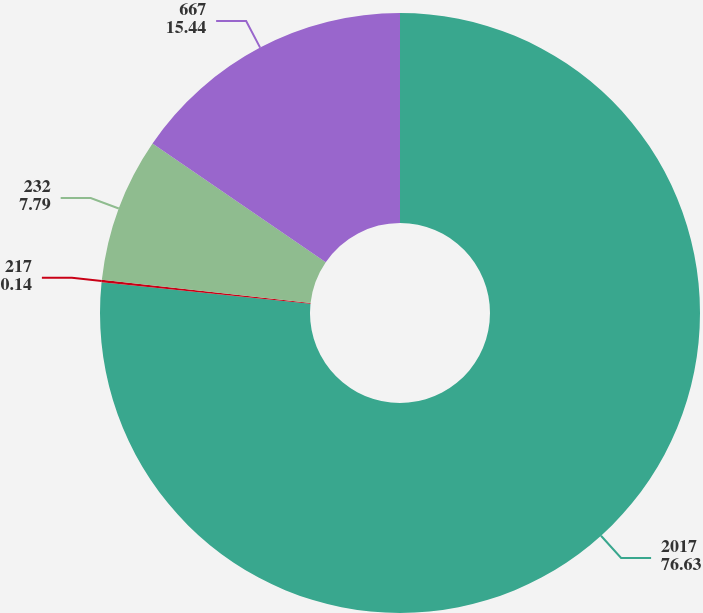Convert chart. <chart><loc_0><loc_0><loc_500><loc_500><pie_chart><fcel>2017<fcel>217<fcel>232<fcel>667<nl><fcel>76.63%<fcel>0.14%<fcel>7.79%<fcel>15.44%<nl></chart> 